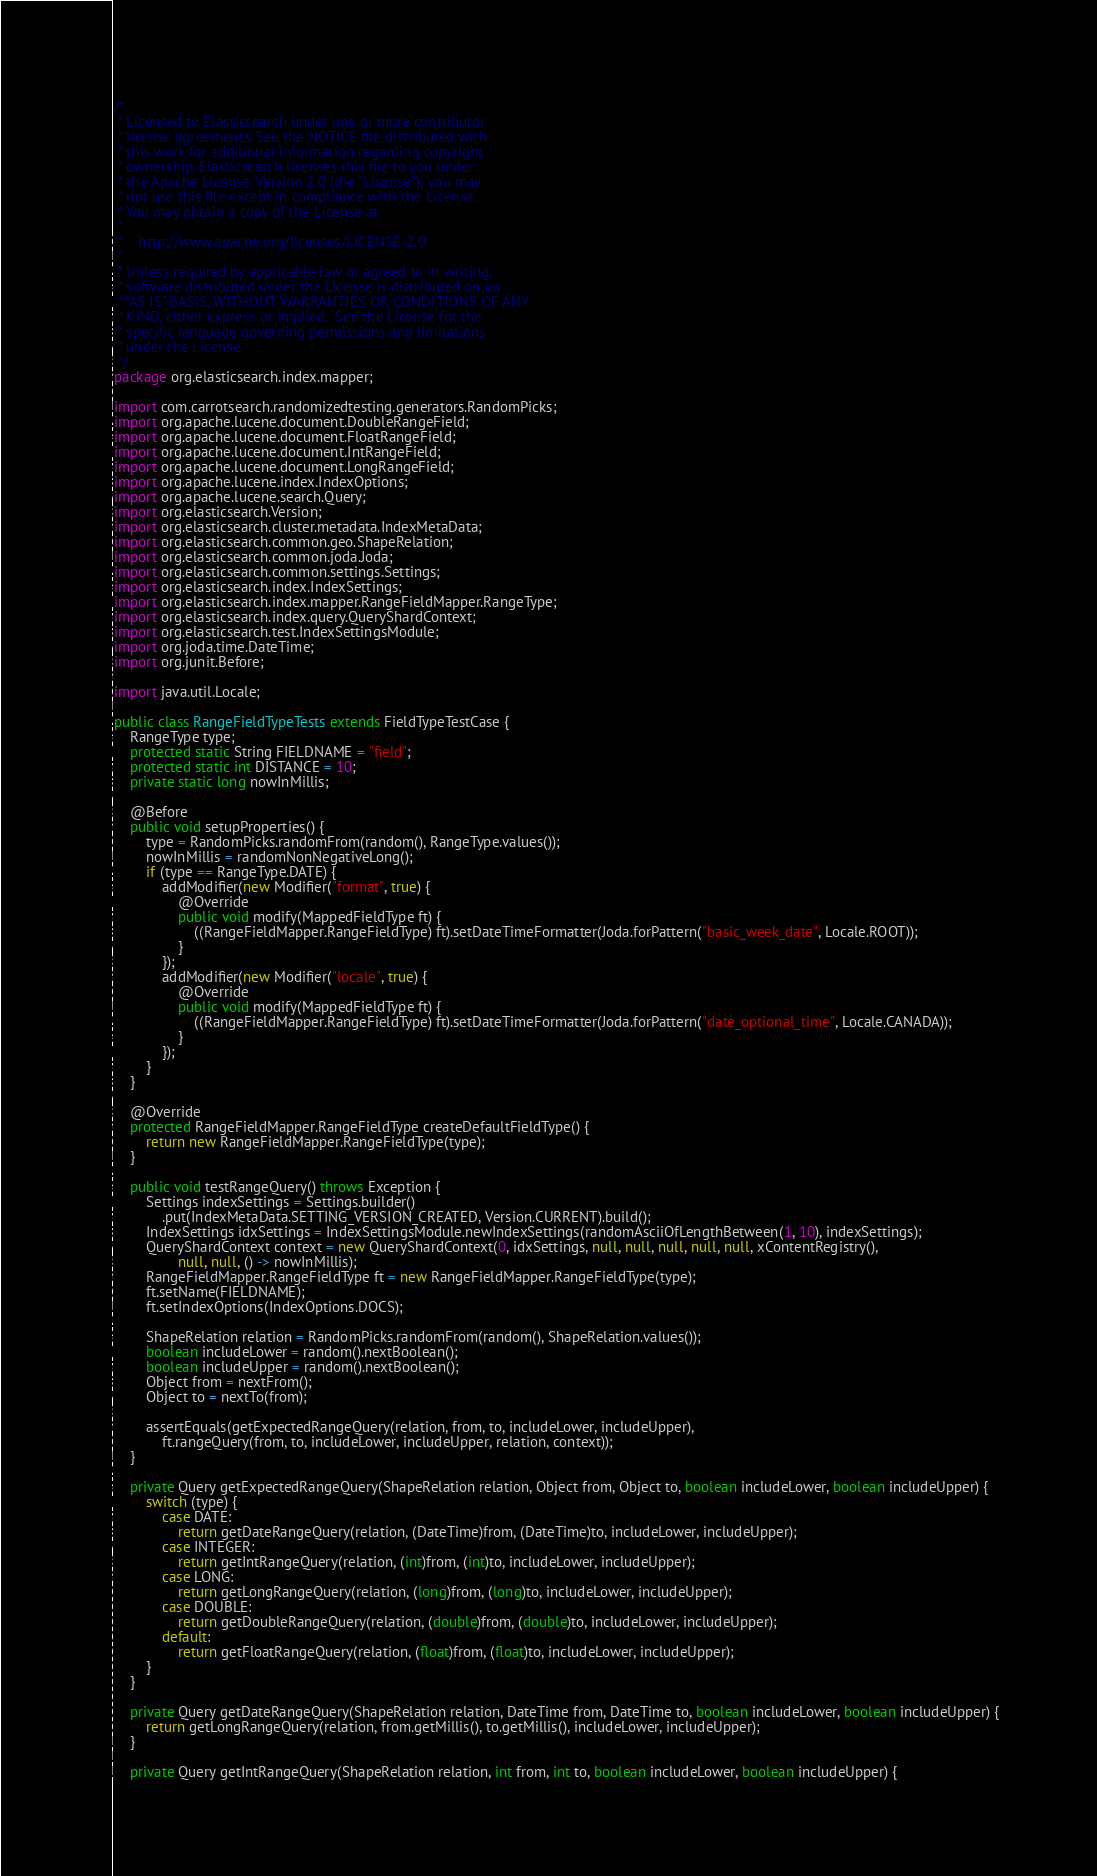<code> <loc_0><loc_0><loc_500><loc_500><_Java_>/*
 * Licensed to Elasticsearch under one or more contributor
 * license agreements. See the NOTICE file distributed with
 * this work for additional information regarding copyright
 * ownership. Elasticsearch licenses this file to you under
 * the Apache License, Version 2.0 (the "License"); you may
 * not use this file except in compliance with the License.
 * You may obtain a copy of the License at
 *
 *    http://www.apache.org/licenses/LICENSE-2.0
 *
 * Unless required by applicable law or agreed to in writing,
 * software distributed under the License is distributed on an
 * "AS IS" BASIS, WITHOUT WARRANTIES OR CONDITIONS OF ANY
 * KIND, either express or implied.  See the License for the
 * specific language governing permissions and limitations
 * under the License.
 */
package org.elasticsearch.index.mapper;

import com.carrotsearch.randomizedtesting.generators.RandomPicks;
import org.apache.lucene.document.DoubleRangeField;
import org.apache.lucene.document.FloatRangeField;
import org.apache.lucene.document.IntRangeField;
import org.apache.lucene.document.LongRangeField;
import org.apache.lucene.index.IndexOptions;
import org.apache.lucene.search.Query;
import org.elasticsearch.Version;
import org.elasticsearch.cluster.metadata.IndexMetaData;
import org.elasticsearch.common.geo.ShapeRelation;
import org.elasticsearch.common.joda.Joda;
import org.elasticsearch.common.settings.Settings;
import org.elasticsearch.index.IndexSettings;
import org.elasticsearch.index.mapper.RangeFieldMapper.RangeType;
import org.elasticsearch.index.query.QueryShardContext;
import org.elasticsearch.test.IndexSettingsModule;
import org.joda.time.DateTime;
import org.junit.Before;

import java.util.Locale;

public class RangeFieldTypeTests extends FieldTypeTestCase {
    RangeType type;
    protected static String FIELDNAME = "field";
    protected static int DISTANCE = 10;
    private static long nowInMillis;

    @Before
    public void setupProperties() {
        type = RandomPicks.randomFrom(random(), RangeType.values());
        nowInMillis = randomNonNegativeLong();
        if (type == RangeType.DATE) {
            addModifier(new Modifier("format", true) {
                @Override
                public void modify(MappedFieldType ft) {
                    ((RangeFieldMapper.RangeFieldType) ft).setDateTimeFormatter(Joda.forPattern("basic_week_date", Locale.ROOT));
                }
            });
            addModifier(new Modifier("locale", true) {
                @Override
                public void modify(MappedFieldType ft) {
                    ((RangeFieldMapper.RangeFieldType) ft).setDateTimeFormatter(Joda.forPattern("date_optional_time", Locale.CANADA));
                }
            });
        }
    }

    @Override
    protected RangeFieldMapper.RangeFieldType createDefaultFieldType() {
        return new RangeFieldMapper.RangeFieldType(type);
    }

    public void testRangeQuery() throws Exception {
        Settings indexSettings = Settings.builder()
            .put(IndexMetaData.SETTING_VERSION_CREATED, Version.CURRENT).build();
        IndexSettings idxSettings = IndexSettingsModule.newIndexSettings(randomAsciiOfLengthBetween(1, 10), indexSettings);
        QueryShardContext context = new QueryShardContext(0, idxSettings, null, null, null, null, null, xContentRegistry(),
                null, null, () -> nowInMillis);
        RangeFieldMapper.RangeFieldType ft = new RangeFieldMapper.RangeFieldType(type);
        ft.setName(FIELDNAME);
        ft.setIndexOptions(IndexOptions.DOCS);

        ShapeRelation relation = RandomPicks.randomFrom(random(), ShapeRelation.values());
        boolean includeLower = random().nextBoolean();
        boolean includeUpper = random().nextBoolean();
        Object from = nextFrom();
        Object to = nextTo(from);

        assertEquals(getExpectedRangeQuery(relation, from, to, includeLower, includeUpper),
            ft.rangeQuery(from, to, includeLower, includeUpper, relation, context));
    }

    private Query getExpectedRangeQuery(ShapeRelation relation, Object from, Object to, boolean includeLower, boolean includeUpper) {
        switch (type) {
            case DATE:
                return getDateRangeQuery(relation, (DateTime)from, (DateTime)to, includeLower, includeUpper);
            case INTEGER:
                return getIntRangeQuery(relation, (int)from, (int)to, includeLower, includeUpper);
            case LONG:
                return getLongRangeQuery(relation, (long)from, (long)to, includeLower, includeUpper);
            case DOUBLE:
                return getDoubleRangeQuery(relation, (double)from, (double)to, includeLower, includeUpper);
            default:
                return getFloatRangeQuery(relation, (float)from, (float)to, includeLower, includeUpper);
        }
    }

    private Query getDateRangeQuery(ShapeRelation relation, DateTime from, DateTime to, boolean includeLower, boolean includeUpper) {
        return getLongRangeQuery(relation, from.getMillis(), to.getMillis(), includeLower, includeUpper);
    }

    private Query getIntRangeQuery(ShapeRelation relation, int from, int to, boolean includeLower, boolean includeUpper) {</code> 